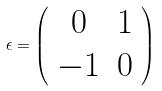Convert formula to latex. <formula><loc_0><loc_0><loc_500><loc_500>\epsilon = \left ( \begin{array} { c c } 0 & 1 \\ - 1 & 0 \end{array} \right )</formula> 